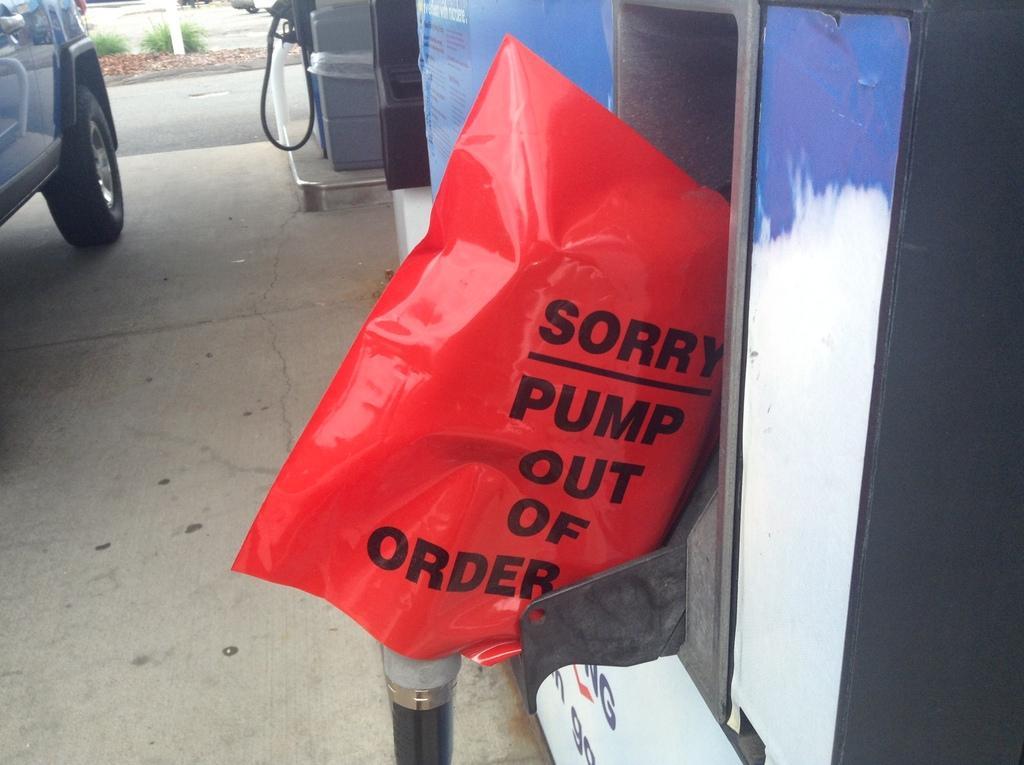Please provide a concise description of this image. In this picture I can see there is a petrol bunk and it has a paper here and there is something written on it and there is a car on to left and the wheel and door of the car is visible and in the backdrop there is a road, there is some grass and a pole in the backdrop. 